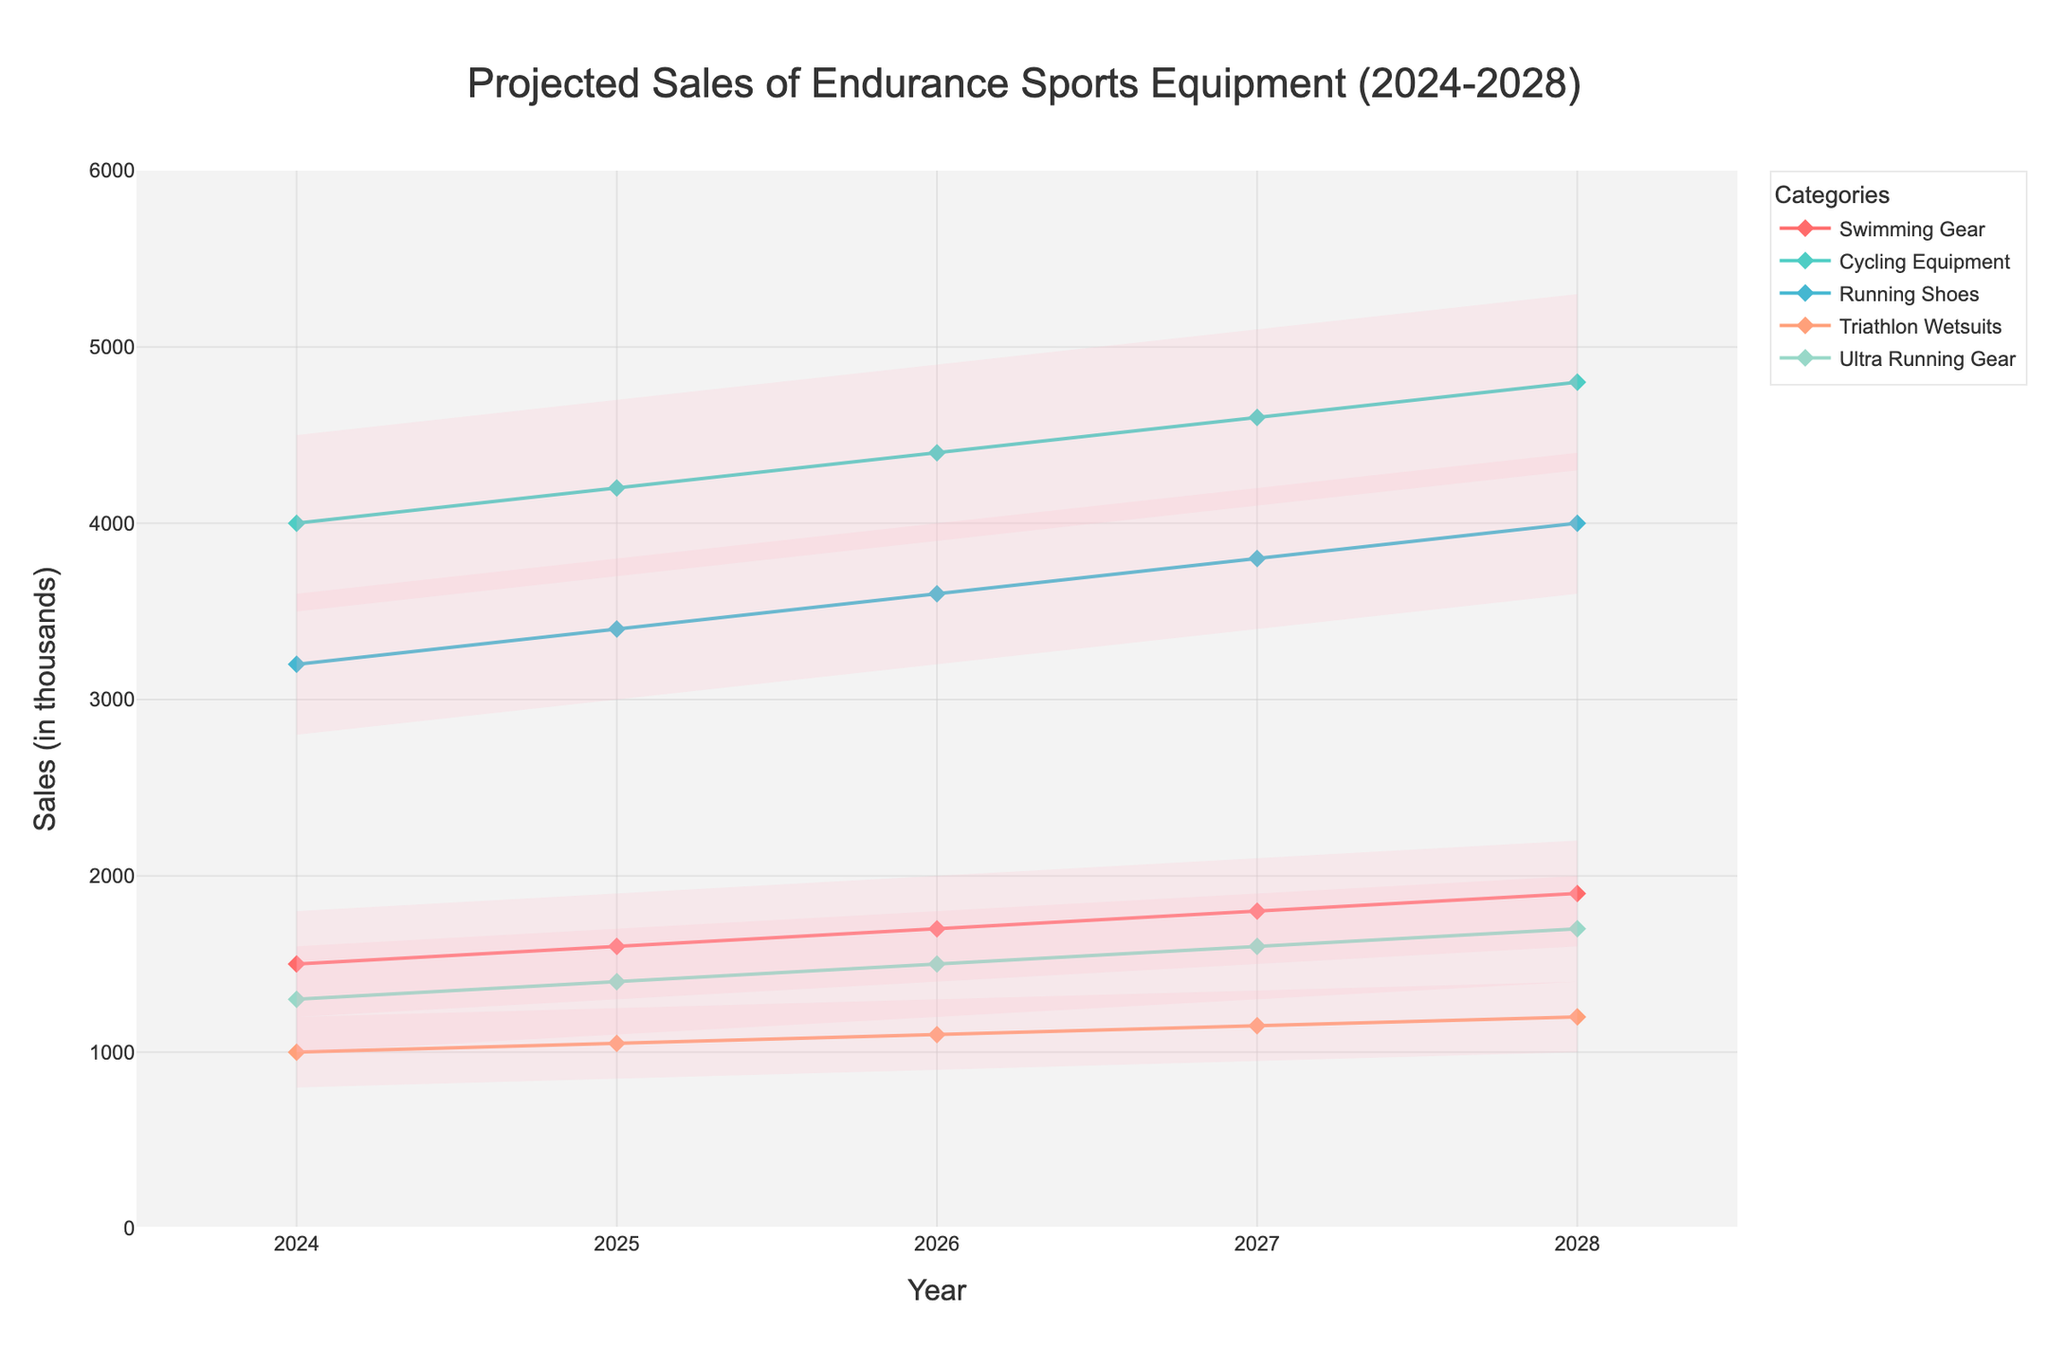what's the title of the chart? The title of the chart can be found at the top center of the figure. The font size is larger and often positioned distinctly.
Answer: Projected Sales of Endurance Sports Equipment (2024-2028) what year has the highest most likely sales projection for Cycling Equipment? To determine this, locate the 'Most Likely' projection line for Cycling Equipment on the chart and identify the year with the highest value along the y-axis.
Answer: 2028 compare the high estimates for Swimming Gear and Ultra Running Gear in 2026. Which one is higher? Find the high estimates for both categories in 2026 on the chart. Compare the y-axis values for both estimates.
Answer: Ultra Running Gear by how much are the most likely sales for Running Shoes expected to increase from 2024 to 2028? Identify the 'Most Likely' sales values for Running Shoes in 2024 and 2028, then subtract the 2024 value from the 2028 value.
Answer: 1200 what is the range of the projected sales estimates for Triathlon Wetsuits in 2027? The range is the difference between the high and low estimates. Find these estimates for Triathlon Wetsuits in 2027 and subtract the low from the high.
Answer: 400 which category shows the most consistent growth in the most likely projections from 2024 to 2028? Analyze the 'Most Likely' projection lines for all the categories from 2024 to 2028, and identify the one with the most steady and smooth upward trend.
Answer: Cycling Equipment what is the average most likely sales projection for Ultra Running Gear across the 5 years shown? Sum the 'Most Likely' sales values for Ultra Running Gear from 2024 to 2028, then divide by 5.
Answer: 1500 how does the projected increase in the most likely sales for Swimming Gear from 2024 to 2028 compare to that for Triathlon Wetsuits? Calculate the increase for both categories by subtracting their 2024 values from their 2028 values. Compare the two resulting values.
Answer: Swimming Gear increase is larger in which year do the high and low estimates for Running Shoes have the widest range? Find the difference between the high and low estimates for Running Shoes in each year from 2024 to 2028. Identify the year with the largest difference.
Answer: 2026 